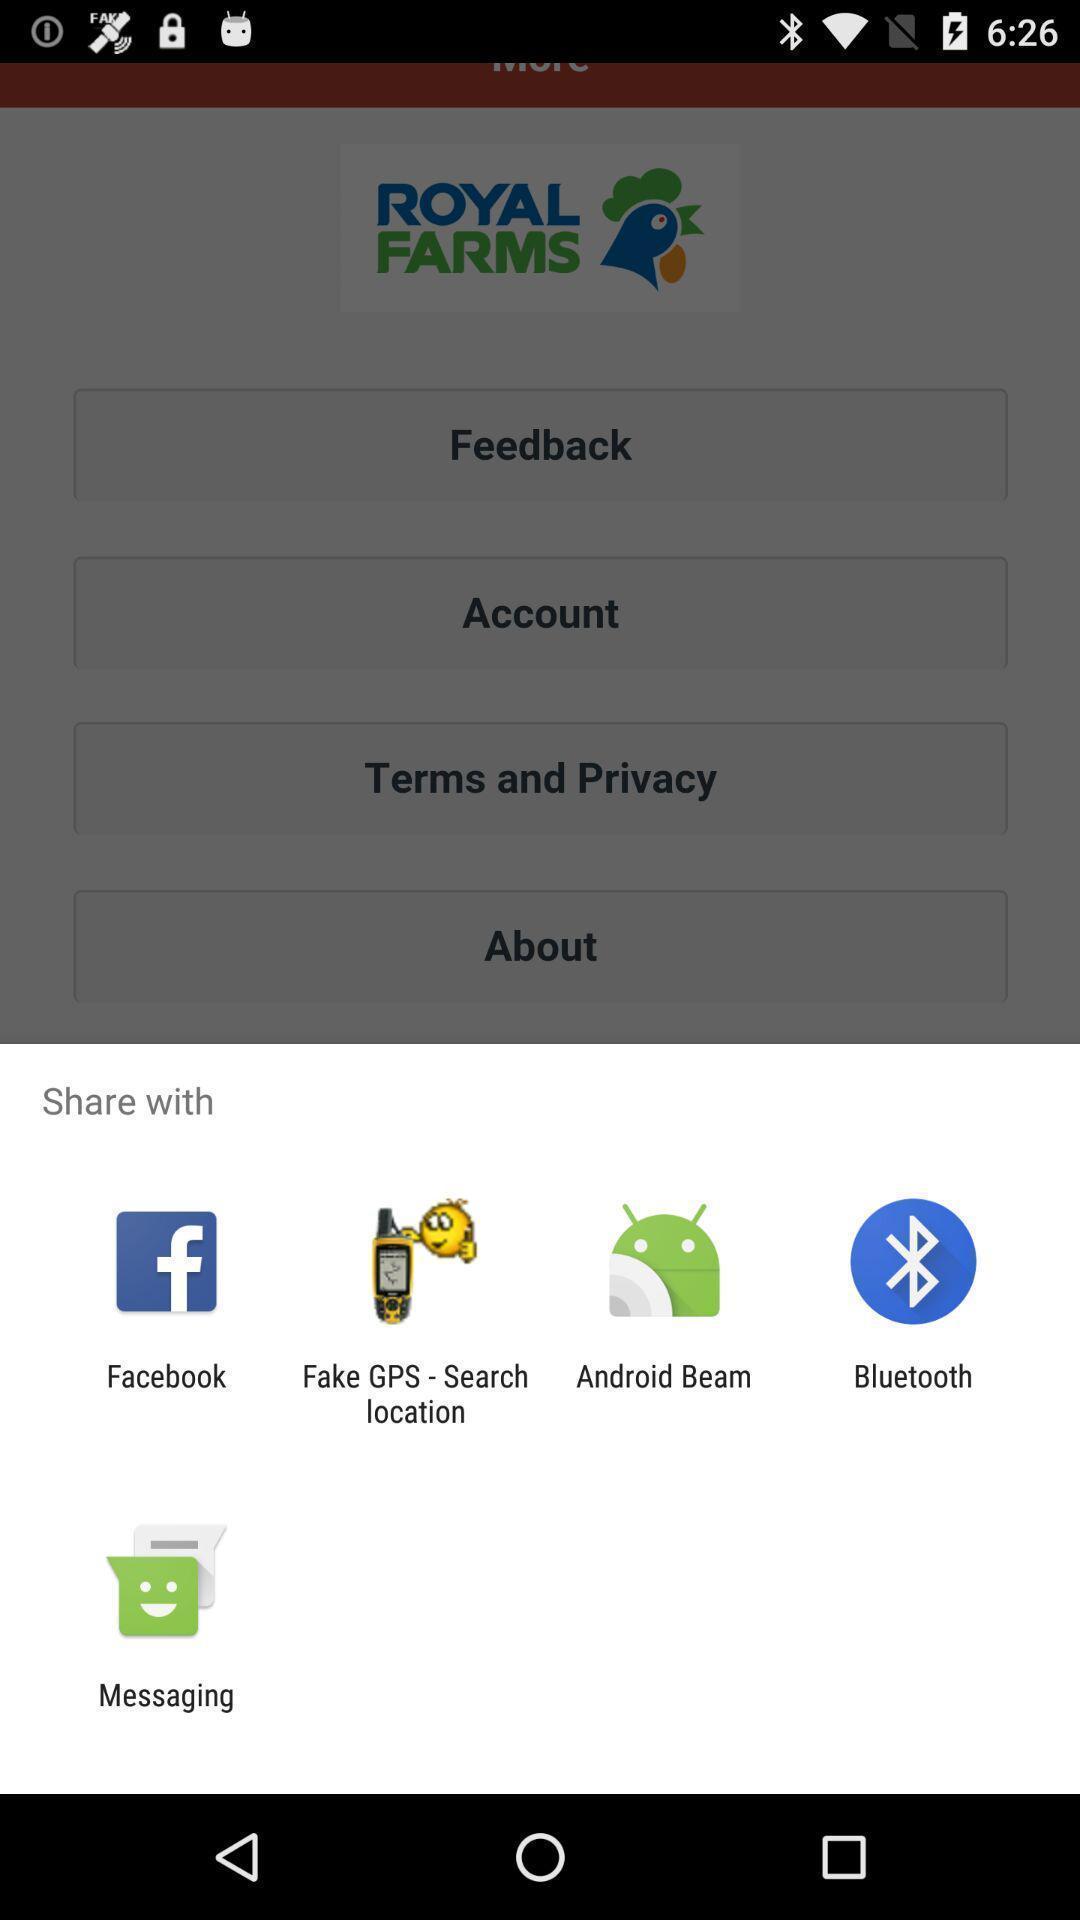What is the overall content of this screenshot? Push up message with multiple share with options. 